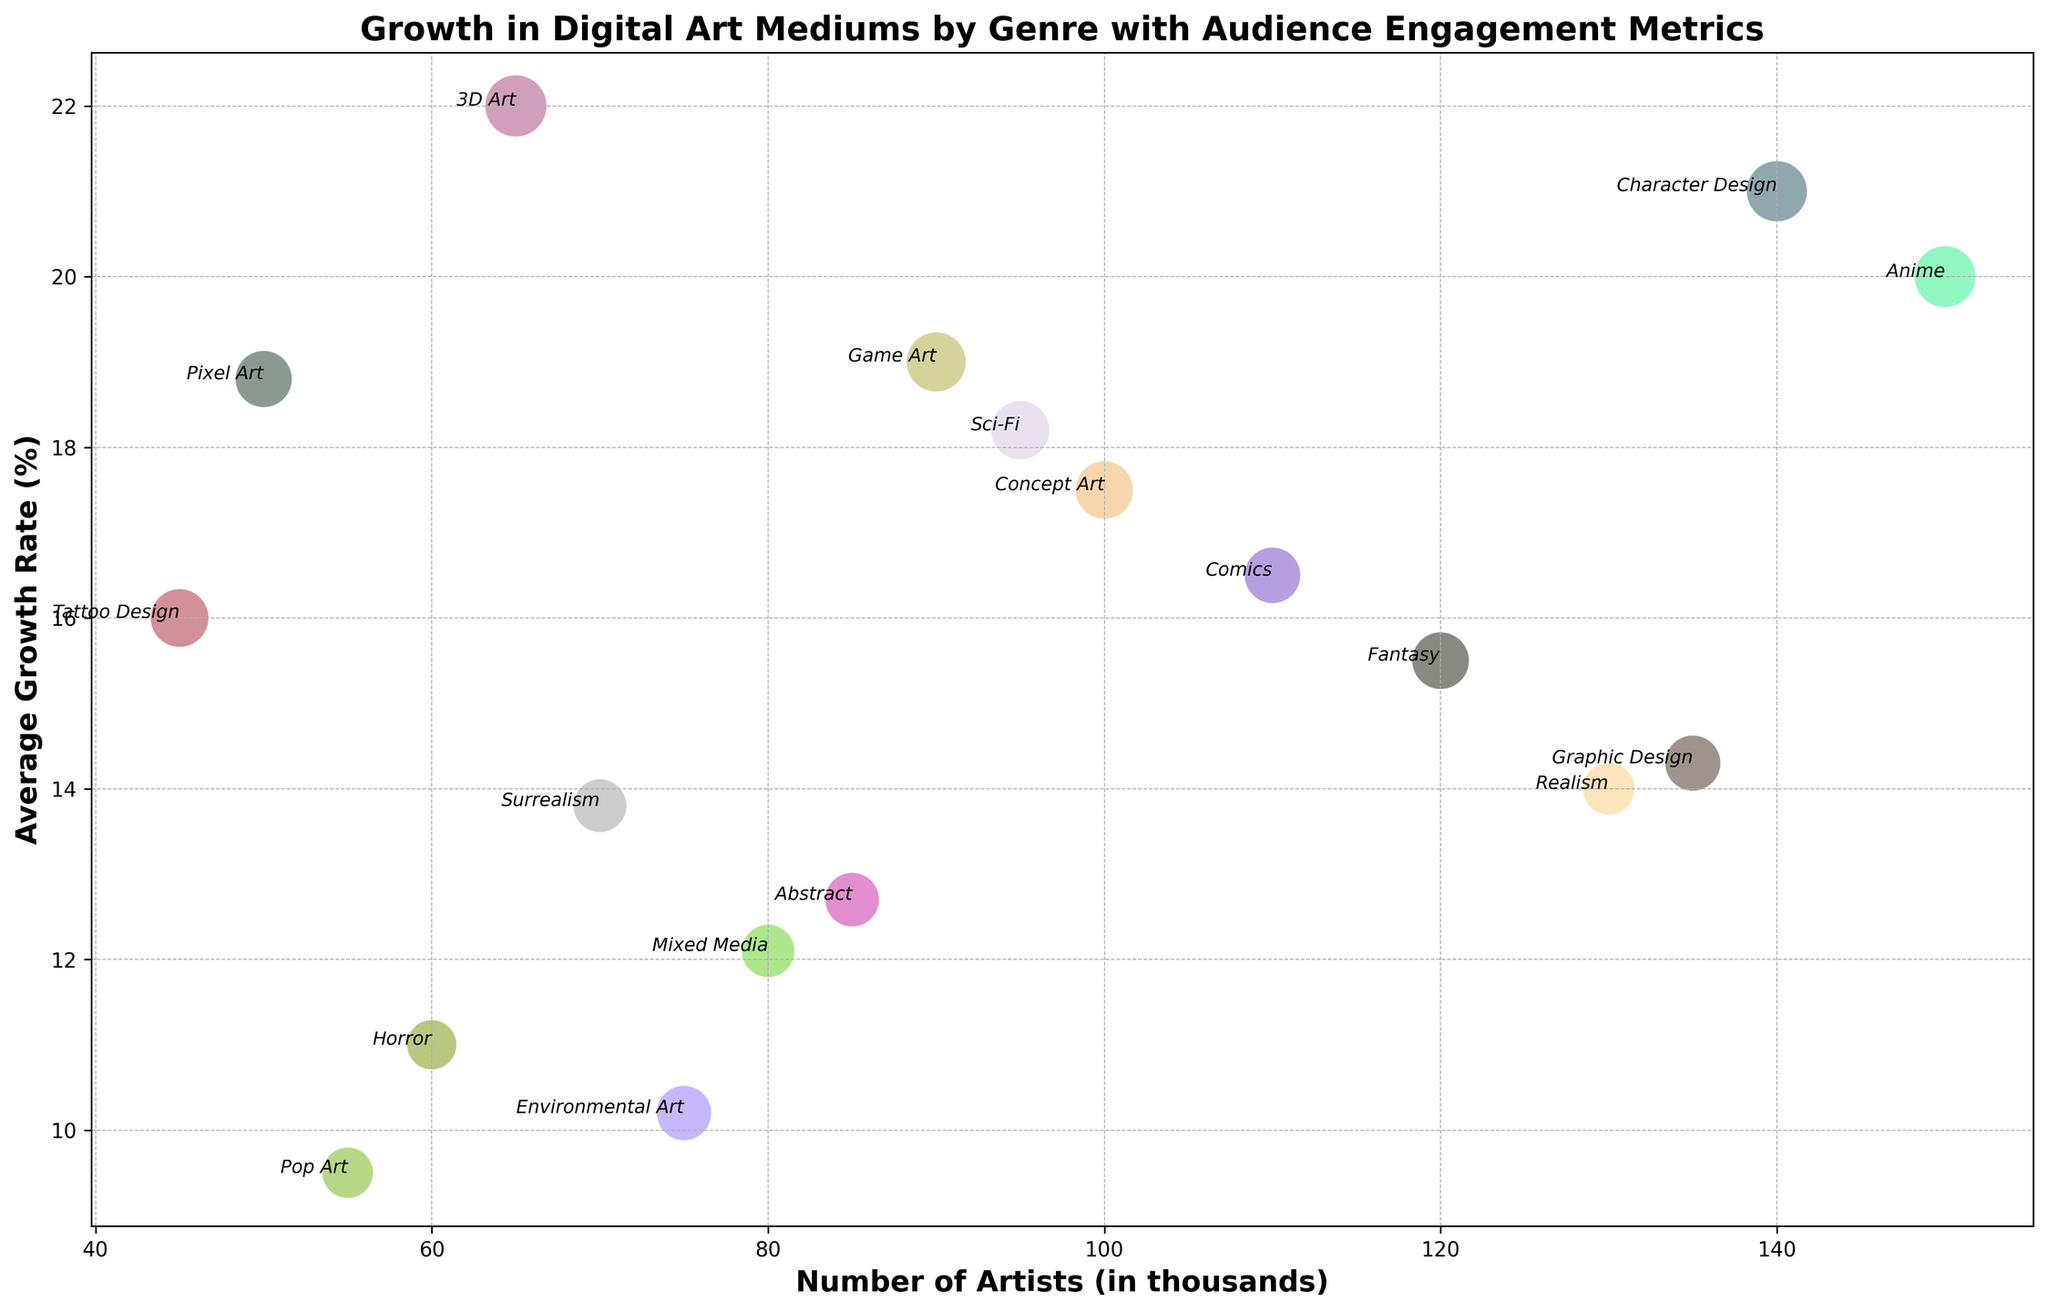Which genre has the highest average growth rate? To determine this, look at the y-axis values and identify the highest point. The genre corresponding to that point is Character Design with a growth rate of 21.0%.
Answer: Character Design Which genre has the largest bubble indicating the highest audience engagement score? Bubbles' sizes indicate the audience engagement score. The largest bubble corresponds to 3D Art.
Answer: 3D Art Which genre has the smallest number of artists but a high engagement score above 80? Identify the smallest bubble on the x-axis while checking its y-axis position to ensure an engagement score above 80. The genre is Tattoo Design with 45 thousand artists and an engagement score of 81.
Answer: Tattoo Design What is the total number of artists for the top three genres with the highest growth rates? Identify the top three genres by growth rate: Character Design, 3D Art, and Anime. Sum their number of artists: 140 + 65 + 150 = 355 thousand artists.
Answer: 355 Which genre has a higher number of artists: Fantasy or Sci-Fi, and by how much? Compare their positions on the x-axis. Fantasy has 120 thousand artists, and Sci-Fi has 95 thousand. The difference is 120 - 95 = 25 thousand artists.
Answer: Fantasy, by 25 thousand Between Comics and Concept Art, which genre has a higher average growth rate, and what is the difference in their growth rates? Look at their y-axis values. Comics has a growth rate of 16.5%, and Concept Art has 17.5%. The difference is 17.5 - 16.5 = 1.0%.
Answer: Concept Art, by 1.0% Which genres have a higher engagement score than average among all the genres? First calculate the average engagement score: (78 + 83 + 65 + 70 + 90 + 75 + 59 + 68 + 80 + 62 + 85 + 88 + 72 + 77 + 91 + 74 + 81 + 67) / 18 = 75.78. Select genres above this score: Fantasy, Sci-Fi, Anime, Comics, Concept Art, Game Art, Character Design, Tattoo Design, 3D Art, and Pixel Art.
Answer: Fantasy, Sci-Fi, Anime, Comics, Concept Art, Game Art, Character Design, Tattoo Design, 3D Art, Pixel Art What is the combined audience engagement score for Sci-Fi and Anime? Add their engagement scores: Sci-Fi (83) + Anime (90) = 173.
Answer: 173 Which genre has the lowest average growth rate and what is that rate? Look at the y-axis to find the lowest point. Pop Art has the lowest growth rate at 9.5%.
Answer: Pop Art, 9.5% Is the engagement score for Environmental Art higher or lower than for Horror, and by how much? Compare their positions on the bubble scale. Environmental Art's score is 72, and Horror's is 59. The difference is 72 - 59 = 13.
Answer: Higher, by 13 